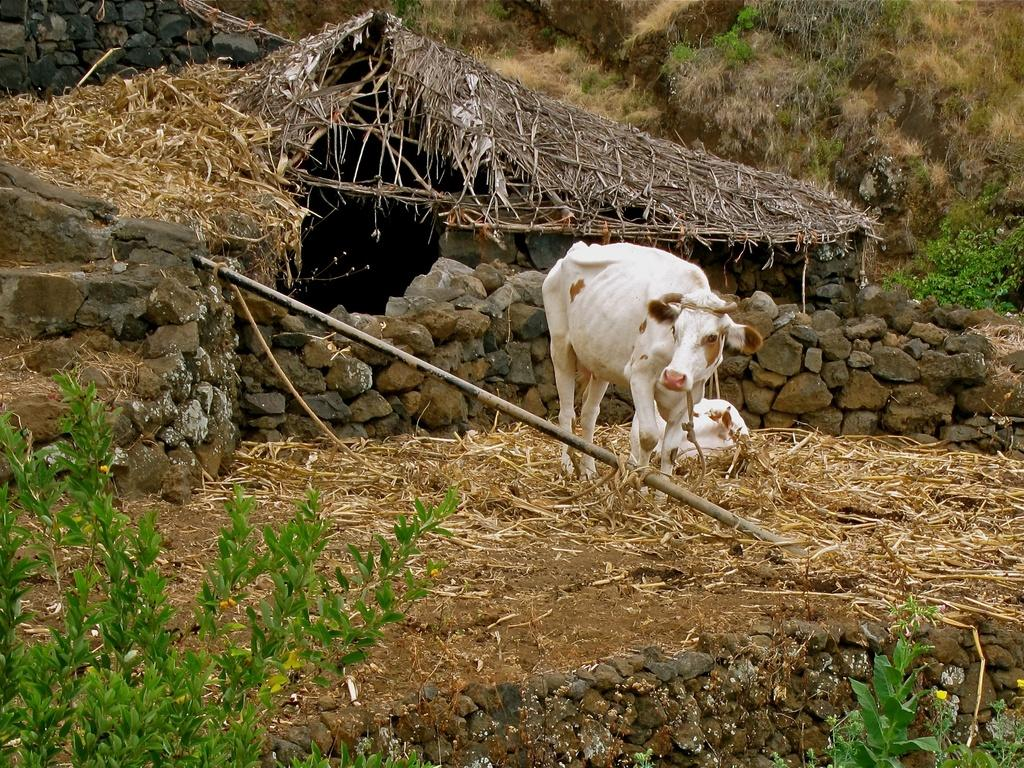What animals can be seen in the image? There are two white cows in the image. What object is present in the image that might be used for restraining or guiding the cows? There is a rope in the image. What type of vegetation is visible in the image? Grass and plants are present in the image. What type of veil is draped over the cows in the image? There is no veil present in the image; the cows are not wearing or draped with any fabric. 